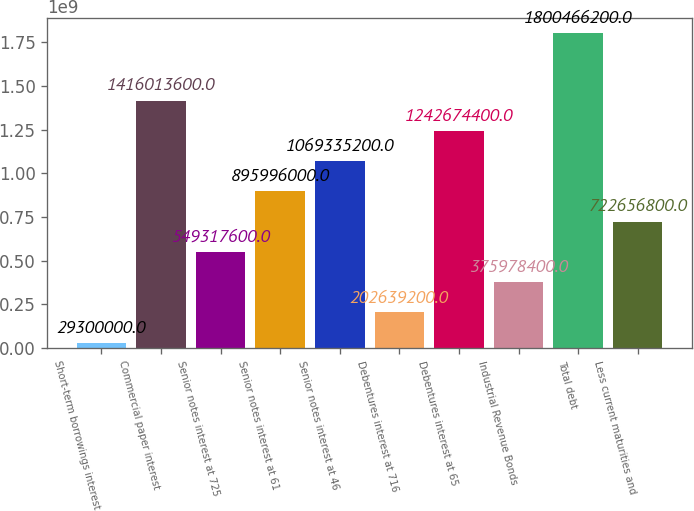Convert chart to OTSL. <chart><loc_0><loc_0><loc_500><loc_500><bar_chart><fcel>Short-term borrowings interest<fcel>Commercial paper interest<fcel>Senior notes interest at 725<fcel>Senior notes interest at 61<fcel>Senior notes interest at 46<fcel>Debentures interest at 716<fcel>Debentures interest at 65<fcel>Industrial Revenue Bonds<fcel>Total debt<fcel>Less current maturities and<nl><fcel>2.93e+07<fcel>1.41601e+09<fcel>5.49318e+08<fcel>8.95996e+08<fcel>1.06934e+09<fcel>2.02639e+08<fcel>1.24267e+09<fcel>3.75978e+08<fcel>1.80047e+09<fcel>7.22657e+08<nl></chart> 